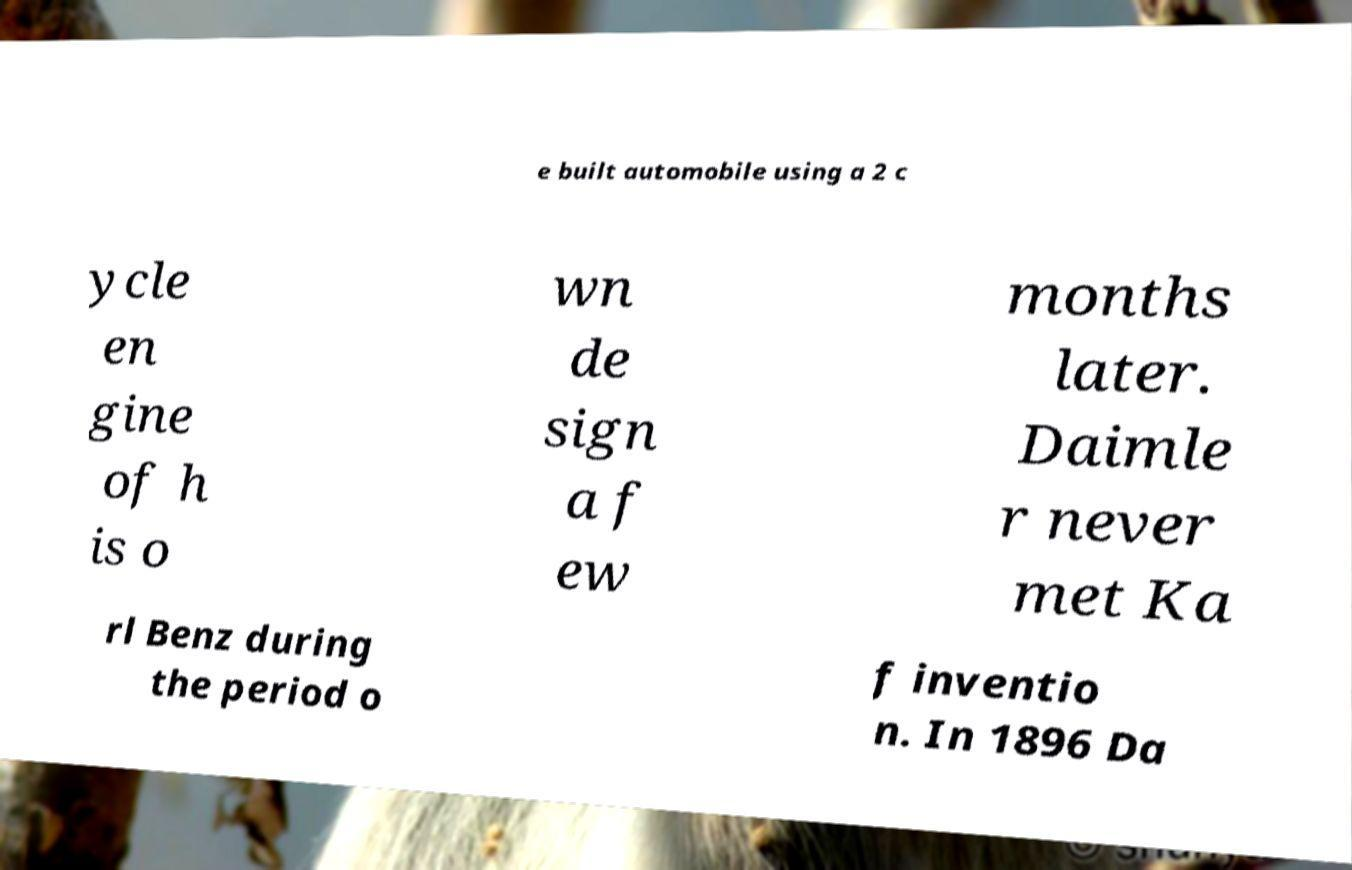Can you read and provide the text displayed in the image?This photo seems to have some interesting text. Can you extract and type it out for me? e built automobile using a 2 c ycle en gine of h is o wn de sign a f ew months later. Daimle r never met Ka rl Benz during the period o f inventio n. In 1896 Da 